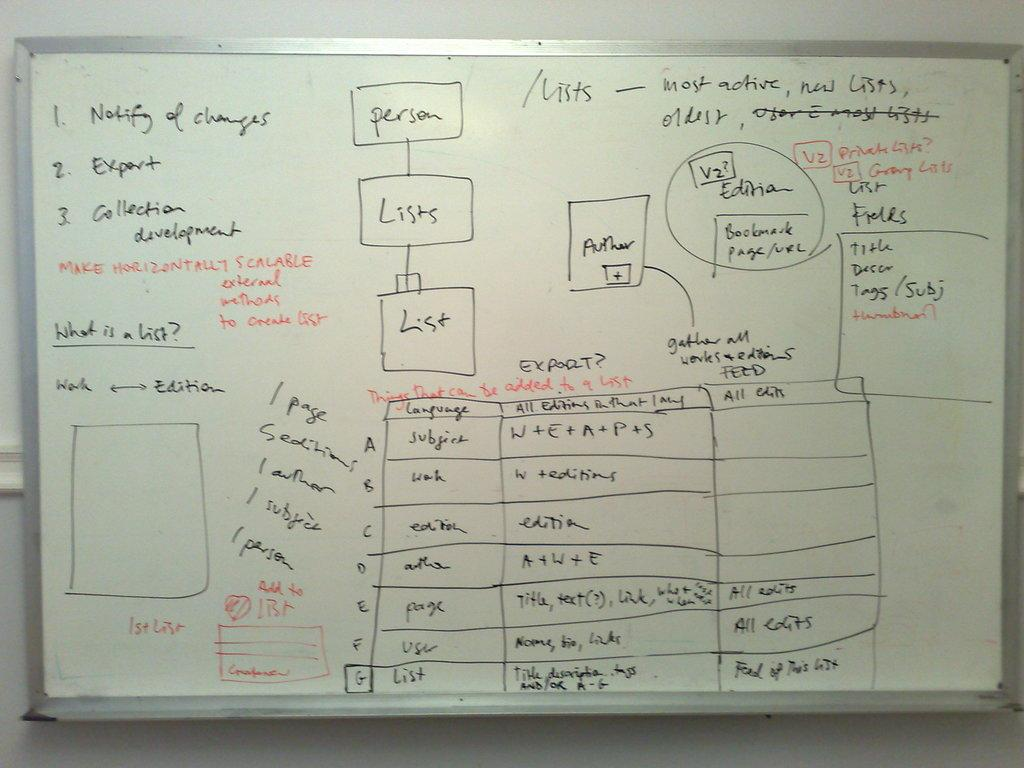<image>
Summarize the visual content of the image. A whiteboard with the makings of a business plan on it 